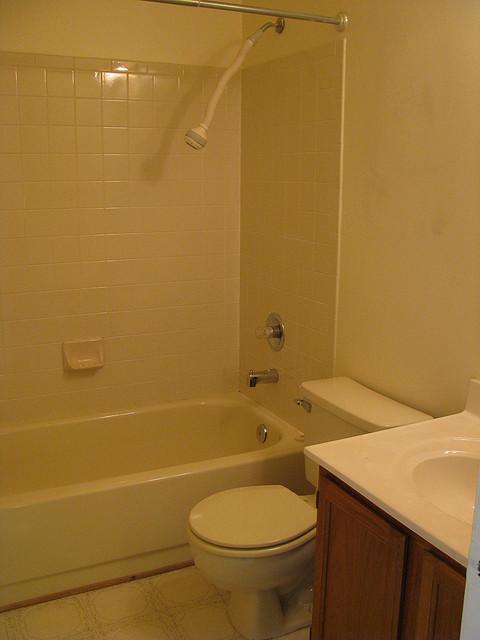Is the toilet next to the sink?
Quick response, please. Yes. If you were to shower here would water get on the floor?
Give a very brief answer. Yes. What color is the tiles?
Short answer required. White. What color is the shower head?
Write a very short answer. White. Is the shower a regular shower?
Be succinct. No. Does the bathtub need a shower curtain?
Answer briefly. Yes. 